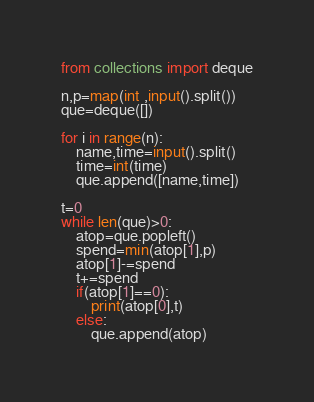Convert code to text. <code><loc_0><loc_0><loc_500><loc_500><_Python_>from collections import deque
 
n,p=map(int ,input().split())
que=deque([])
 
for i in range(n):
    name,time=input().split()
    time=int(time)
    que.append([name,time])
 
t=0
while len(que)>0:
    atop=que.popleft()
    spend=min(atop[1],p)
    atop[1]-=spend
    t+=spend
    if(atop[1]==0):
        print(atop[0],t)
    else:
        que.append(atop)
</code> 